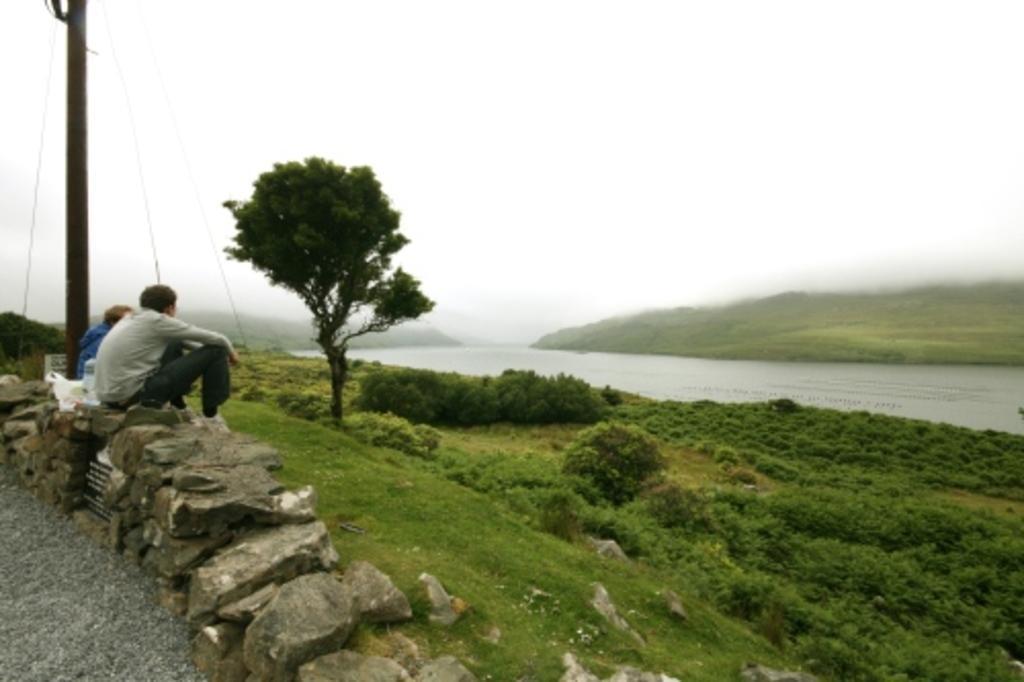How would you summarize this image in a sentence or two? As we can see in the image there is grass, plants, tree, rocks, current pole, two people sitting on rocks and there is water. At the top there is sky. 